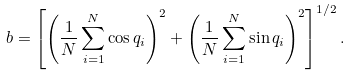<formula> <loc_0><loc_0><loc_500><loc_500>b = \left [ \left ( \frac { 1 } { N } \sum _ { i = 1 } ^ { N } \cos q _ { i } \right ) ^ { 2 } + \left ( \frac { 1 } { N } \sum _ { i = 1 } ^ { N } \sin q _ { i } \right ) ^ { 2 } \right ] ^ { 1 / 2 } .</formula> 